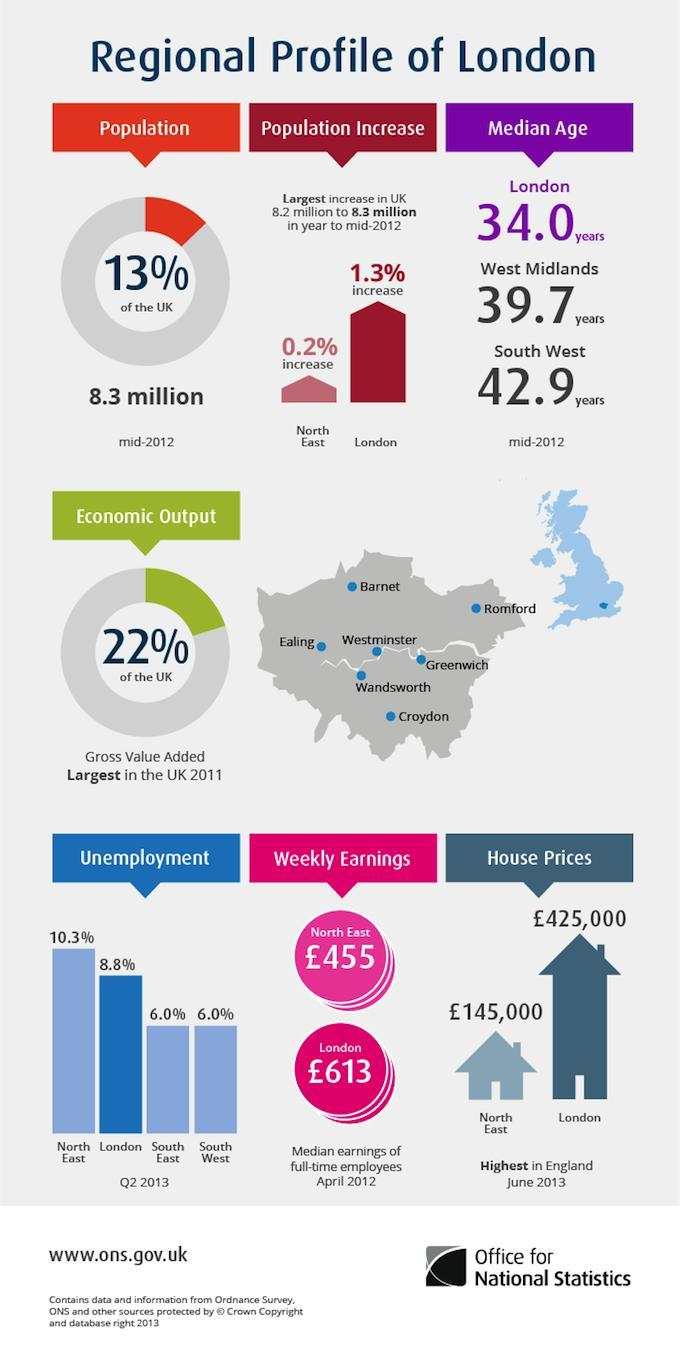What is the difference in house prices in North East and London in Pounds?
Answer the question with a short phrase. 280,000 Which region has higher median weekly earnings- North East or London? London Which two regions have an unemployment rate of 6% each? South East, South West How many regions have been considered for unemployment statistics? 4 What is the percentage increase in population between North East and London? 1.1% What percent of total UK population is in London? 13% of the UK What is the difference in unemployment rates between North East and London? 1.5% What is the difference of ages in West Midlands with median age in London? 5.7 years 